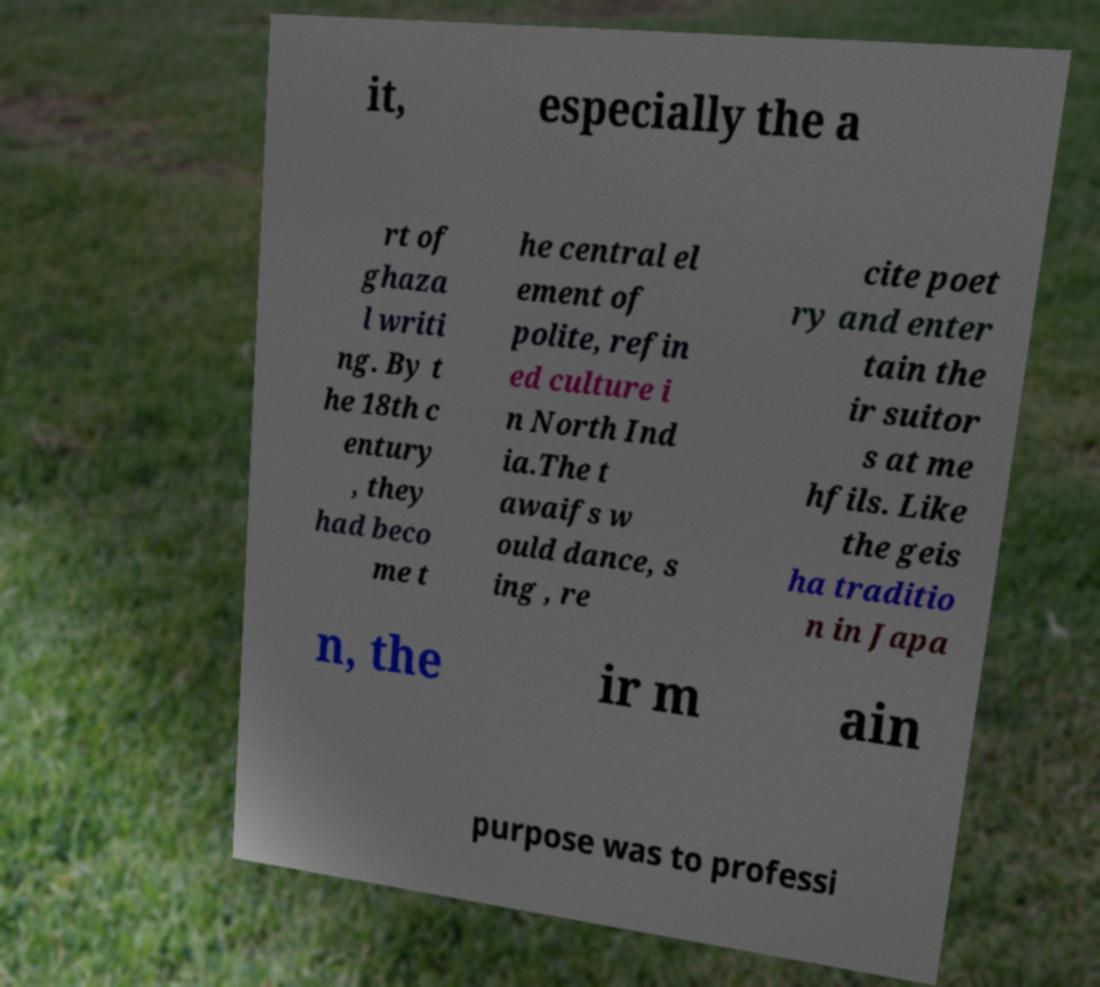I need the written content from this picture converted into text. Can you do that? it, especially the a rt of ghaza l writi ng. By t he 18th c entury , they had beco me t he central el ement of polite, refin ed culture i n North Ind ia.The t awaifs w ould dance, s ing , re cite poet ry and enter tain the ir suitor s at me hfils. Like the geis ha traditio n in Japa n, the ir m ain purpose was to professi 